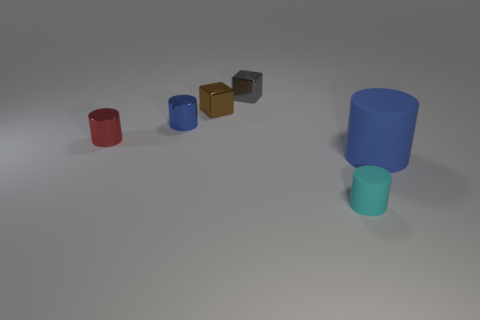How many things are either blue things behind the big matte thing or blue metal objects?
Your answer should be very brief. 1. Is the number of big objects behind the small blue metal cylinder greater than the number of blue cylinders that are behind the big blue matte object?
Your answer should be very brief. No. What size is the other cylinder that is the same color as the big matte cylinder?
Your answer should be compact. Small. Does the red shiny cylinder have the same size as the blue cylinder that is left of the blue rubber thing?
Your response must be concise. Yes. How many spheres are either tiny yellow metallic objects or small cyan matte things?
Provide a short and direct response. 0. What is the size of the red thing that is made of the same material as the gray thing?
Your answer should be compact. Small. Do the blue object on the right side of the brown metallic thing and the shiny thing that is right of the small brown cube have the same size?
Offer a terse response. No. What number of things are either tiny gray shiny things or tiny red shiny cylinders?
Ensure brevity in your answer.  2. The cyan object has what shape?
Provide a short and direct response. Cylinder. There is a gray metallic object that is the same shape as the tiny brown thing; what size is it?
Give a very brief answer. Small. 